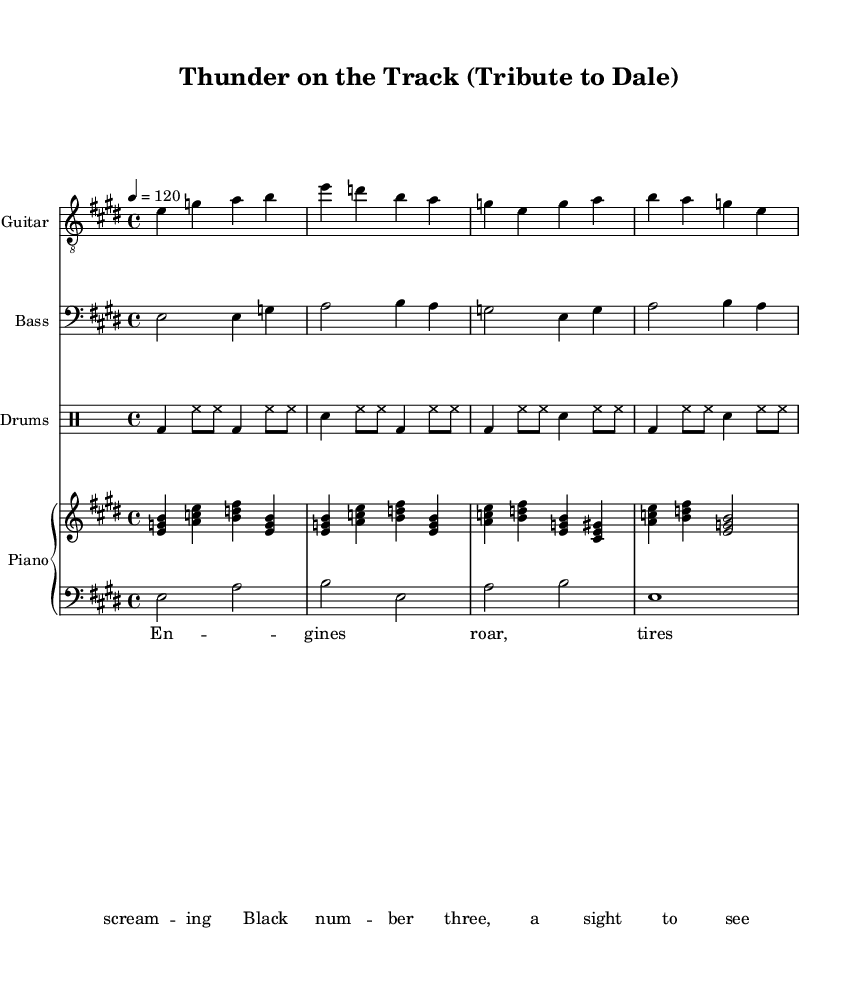What is the key signature of this music? The key signature is indicated at the beginning of the score, displaying two sharps. This means it is in E major.
Answer: E major What is the time signature of this music? The time signature is found in the initial part of the score and indicates that there are four beats per measure, which is represented as 4/4.
Answer: 4/4 What is the tempo of this music? The tempo marking, indicated at the beginning of the score, states "4 = 120," meaning there are 120 beats per minute.
Answer: 120 How many measures are there in the electric guitar part? By counting the number of vertical lines (bar lines) in the electric guitar notation, we find a total of 8 measures.
Answer: 8 What instruments are included in this score? The score includes multiple staves for different instruments; specifically listed are Electric Guitar, Bass, Drums, and Piano (with Right Hand and Left Hand parts).
Answer: Electric Guitar, Bass, Drums, Piano What is the primary lyrical theme of the song? The lyrics describe the exhilarating sounds of engines and a specific reference to "Black number three," which evokes the image of Dale Earnhardt's famous car.
Answer: Racing How many beats are there in the first measure of the drums part? The first measure in the drum part has four beats, as indicated by the 4/4 time signature, with distinct drum hits marking each beat.
Answer: 4 